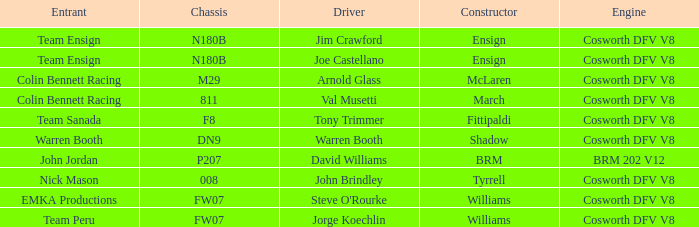Who built Warren Booth's car with the Cosworth DFV V8 engine? Shadow. I'm looking to parse the entire table for insights. Could you assist me with that? {'header': ['Entrant', 'Chassis', 'Driver', 'Constructor', 'Engine'], 'rows': [['Team Ensign', 'N180B', 'Jim Crawford', 'Ensign', 'Cosworth DFV V8'], ['Team Ensign', 'N180B', 'Joe Castellano', 'Ensign', 'Cosworth DFV V8'], ['Colin Bennett Racing', 'M29', 'Arnold Glass', 'McLaren', 'Cosworth DFV V8'], ['Colin Bennett Racing', '811', 'Val Musetti', 'March', 'Cosworth DFV V8'], ['Team Sanada', 'F8', 'Tony Trimmer', 'Fittipaldi', 'Cosworth DFV V8'], ['Warren Booth', 'DN9', 'Warren Booth', 'Shadow', 'Cosworth DFV V8'], ['John Jordan', 'P207', 'David Williams', 'BRM', 'BRM 202 V12'], ['Nick Mason', '008', 'John Brindley', 'Tyrrell', 'Cosworth DFV V8'], ['EMKA Productions', 'FW07', "Steve O'Rourke", 'Williams', 'Cosworth DFV V8'], ['Team Peru', 'FW07', 'Jorge Koechlin', 'Williams', 'Cosworth DFV V8']]} 